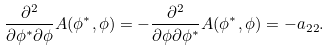Convert formula to latex. <formula><loc_0><loc_0><loc_500><loc_500>\frac { \partial ^ { 2 } } { \partial \phi ^ { * } \partial \phi } A ( \phi ^ { * } , \phi ) = - \frac { \partial ^ { 2 } } { \partial \phi \partial \phi ^ { * } } A ( \phi ^ { * } , \phi ) = - a _ { 2 2 } .</formula> 